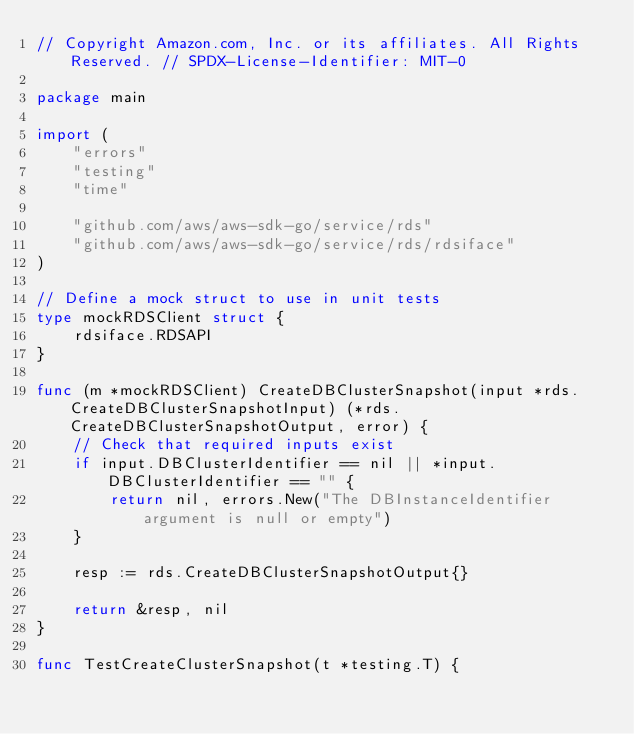Convert code to text. <code><loc_0><loc_0><loc_500><loc_500><_Go_>// Copyright Amazon.com, Inc. or its affiliates. All Rights Reserved. // SPDX-License-Identifier: MIT-0

package main

import (
    "errors"
    "testing"
    "time"

    "github.com/aws/aws-sdk-go/service/rds"
    "github.com/aws/aws-sdk-go/service/rds/rdsiface"
)

// Define a mock struct to use in unit tests
type mockRDSClient struct {
    rdsiface.RDSAPI
}

func (m *mockRDSClient) CreateDBClusterSnapshot(input *rds.CreateDBClusterSnapshotInput) (*rds.CreateDBClusterSnapshotOutput, error) {
    // Check that required inputs exist
    if input.DBClusterIdentifier == nil || *input.DBClusterIdentifier == "" {
        return nil, errors.New("The DBInstanceIdentifier argument is null or empty")
    }

    resp := rds.CreateDBClusterSnapshotOutput{}

    return &resp, nil
}

func TestCreateClusterSnapshot(t *testing.T) {</code> 